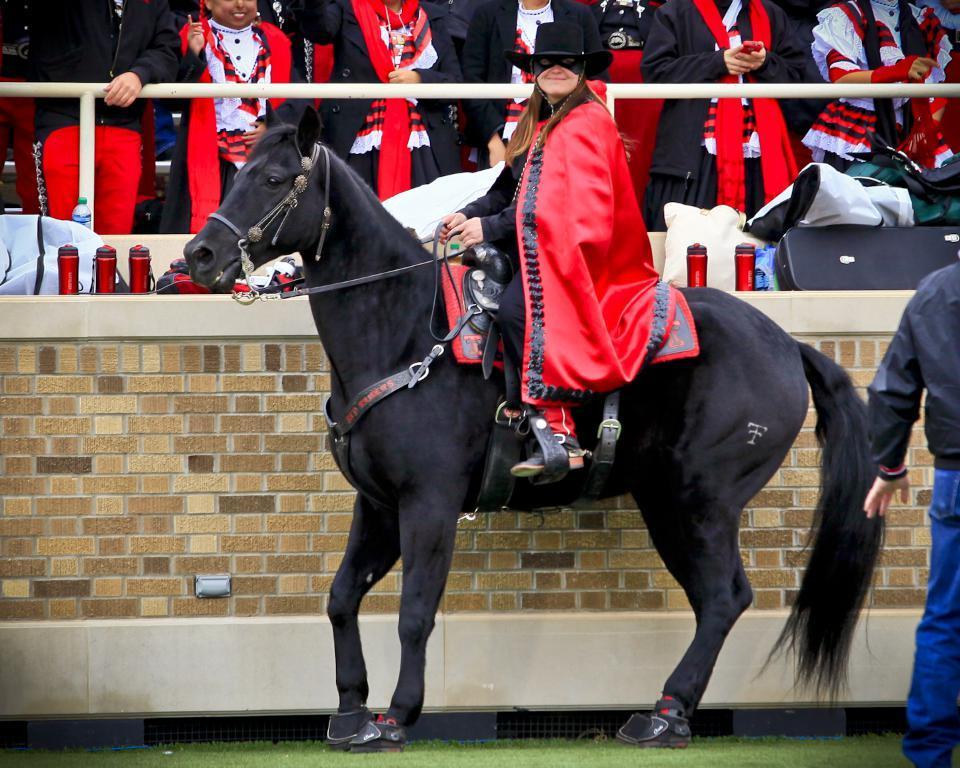Can you describe this image briefly? Here we can see a woman sitting on the horse and she is smiling, and at back here a group of persons are standing, and in front here are some objects on it, and here is the wall made of bricks. 